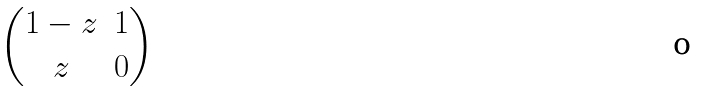Convert formula to latex. <formula><loc_0><loc_0><loc_500><loc_500>\begin{pmatrix} 1 - z & 1 \\ z & 0 \end{pmatrix}</formula> 